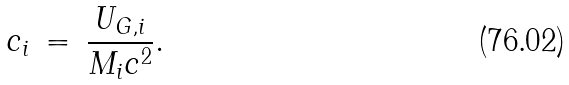Convert formula to latex. <formula><loc_0><loc_0><loc_500><loc_500>c _ { i } \, = \, \frac { U _ { G , i } } { M _ { i } c ^ { 2 } } .</formula> 